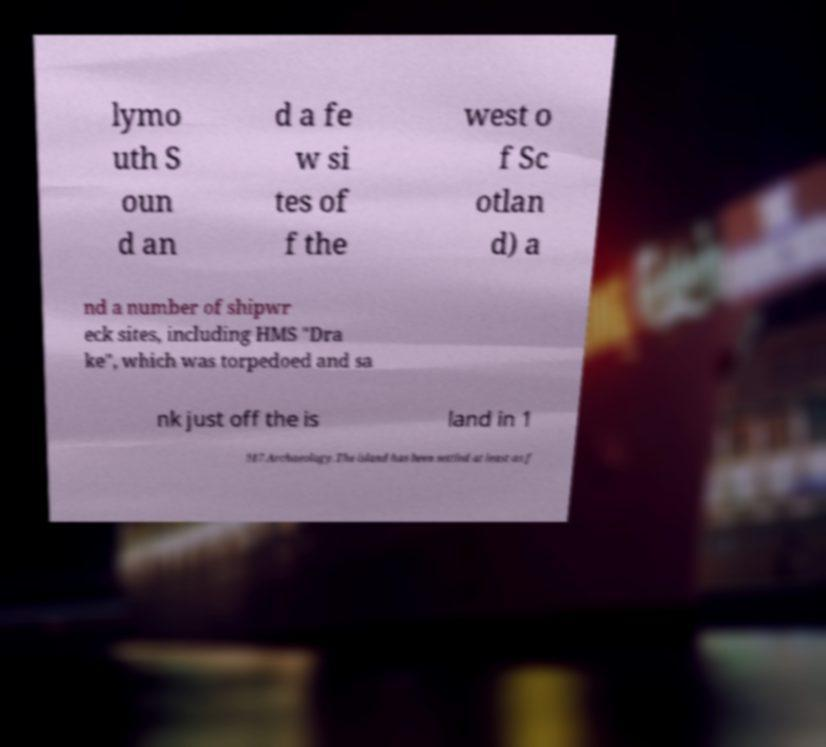There's text embedded in this image that I need extracted. Can you transcribe it verbatim? lymo uth S oun d an d a fe w si tes of f the west o f Sc otlan d) a nd a number of shipwr eck sites, including HMS "Dra ke", which was torpedoed and sa nk just off the is land in 1 917.Archaeology.The island has been settled at least as f 